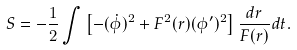<formula> <loc_0><loc_0><loc_500><loc_500>S = - \frac { 1 } { 2 } \int \left [ - ( \dot { \phi } ) ^ { 2 } + F ^ { 2 } ( r ) ( \phi ^ { \prime } ) ^ { 2 } \right ] \frac { d r } { F ( r ) } d t .</formula> 